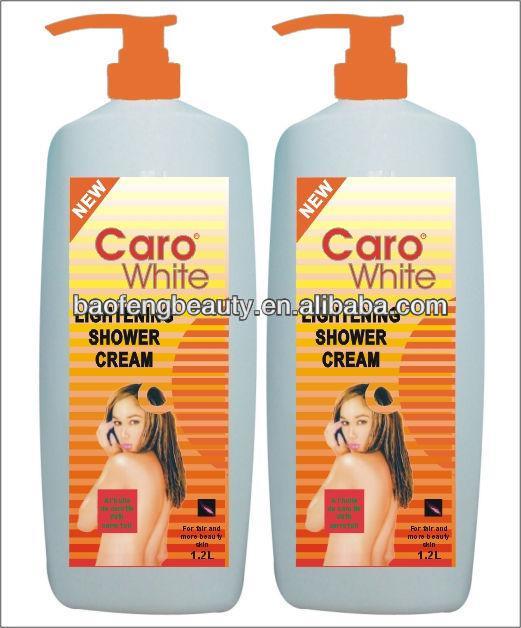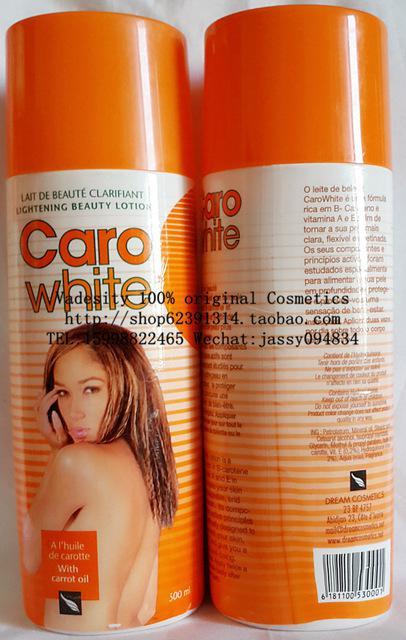The first image is the image on the left, the second image is the image on the right. For the images shown, is this caption "One product is sitting on its box." true? Answer yes or no. No. 